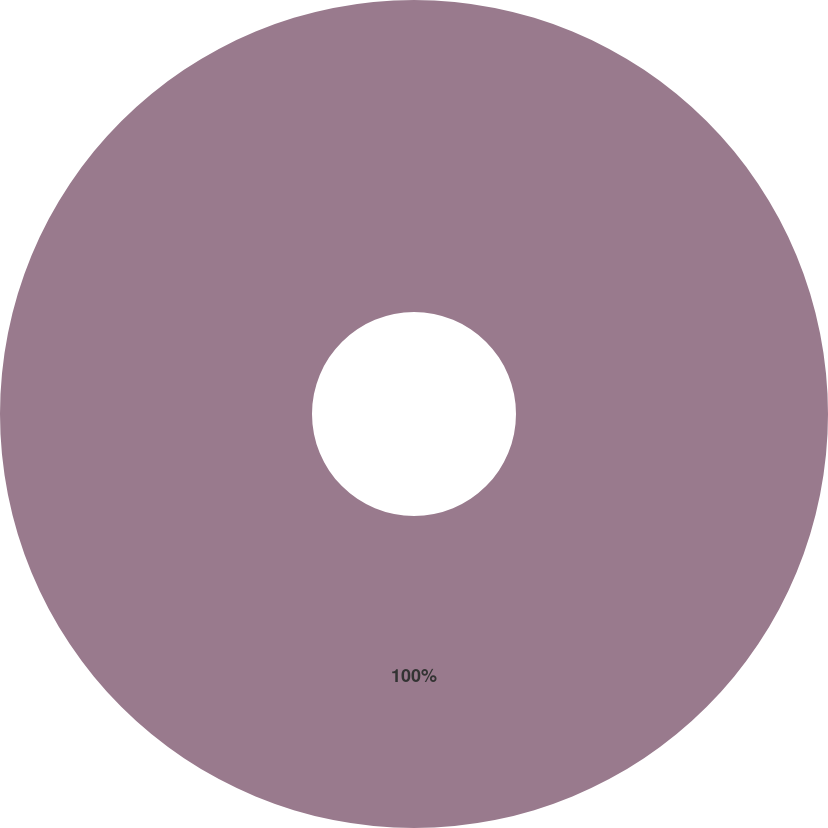Convert chart to OTSL. <chart><loc_0><loc_0><loc_500><loc_500><pie_chart><ecel><nl><fcel>100.0%<nl></chart> 